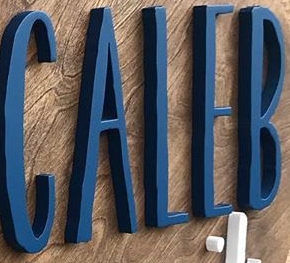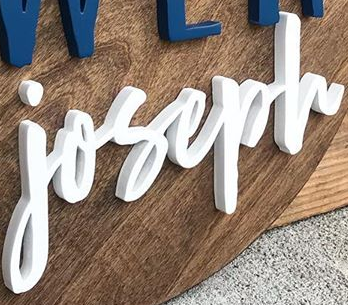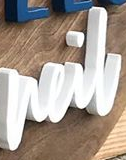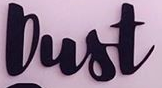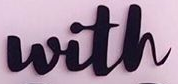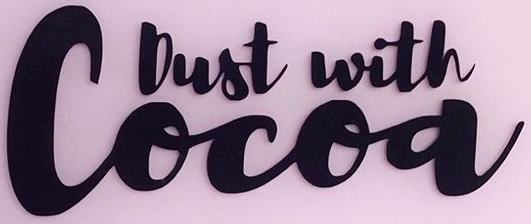Read the text content from these images in order, separated by a semicolon. CALEB; joseph; neil; Dust; with; Cocoa 